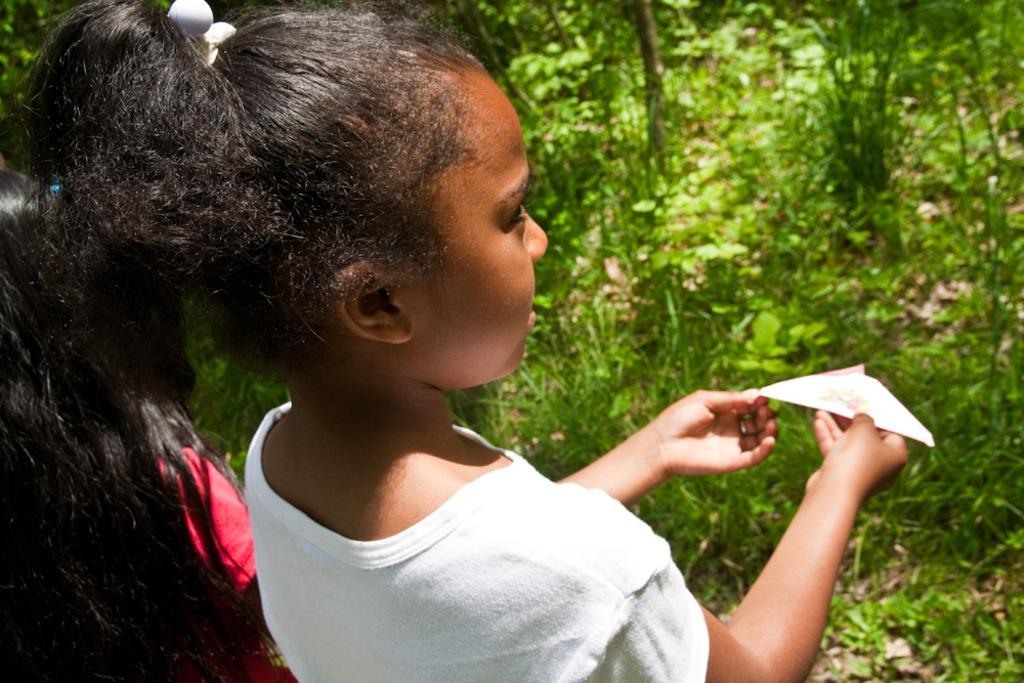In one or two sentences, can you explain what this image depicts? In this image there is a girl standing, holding a paper cloth in her hand, beside the girl there is another girl, in front of the girl there is grass and trees. 